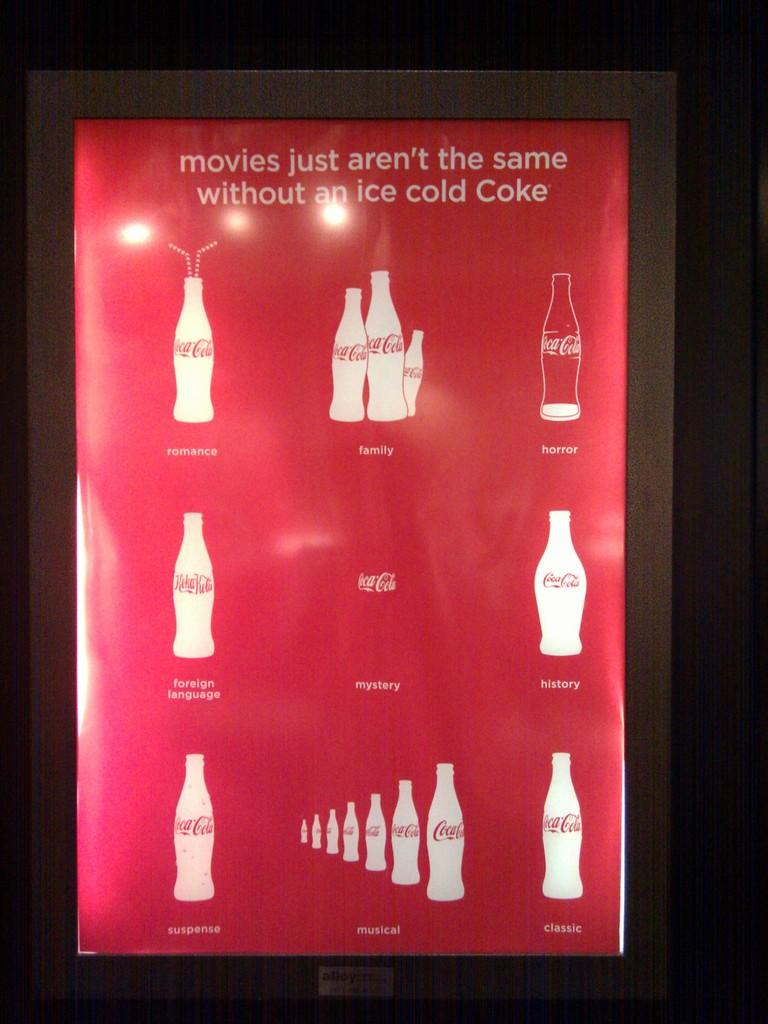<image>
Render a clear and concise summary of the photo. a coca cola poster that says 'movies just aren't the same without an ice cold coke' 